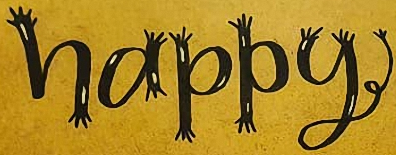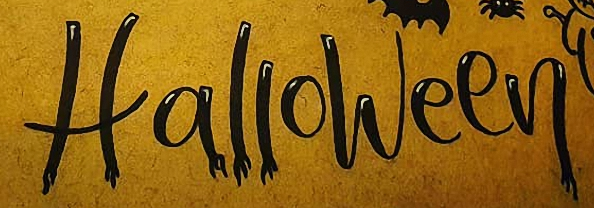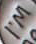What words can you see in these images in sequence, separated by a semicolon? happy; Halloween; I'M 